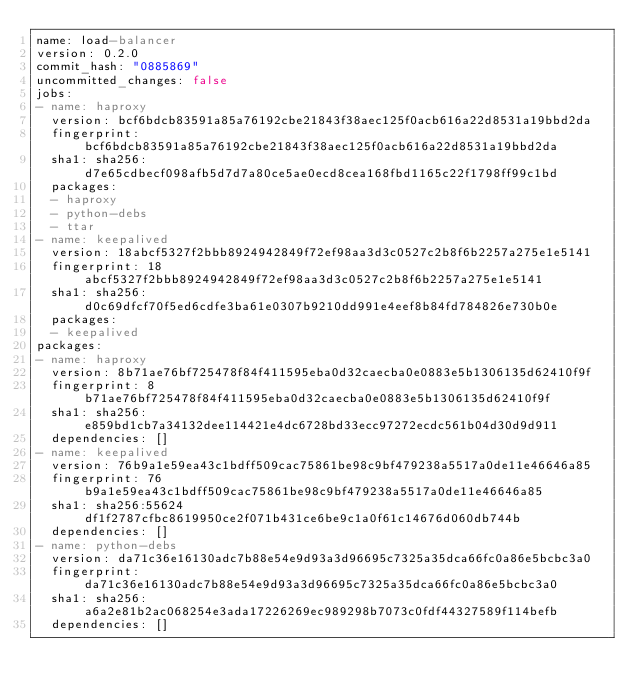<code> <loc_0><loc_0><loc_500><loc_500><_YAML_>name: load-balancer
version: 0.2.0
commit_hash: "0885869"
uncommitted_changes: false
jobs:
- name: haproxy
  version: bcf6bdcb83591a85a76192cbe21843f38aec125f0acb616a22d8531a19bbd2da
  fingerprint: bcf6bdcb83591a85a76192cbe21843f38aec125f0acb616a22d8531a19bbd2da
  sha1: sha256:d7e65cdbecf098afb5d7d7a80ce5ae0ecd8cea168fbd1165c22f1798ff99c1bd
  packages:
  - haproxy
  - python-debs
  - ttar
- name: keepalived
  version: 18abcf5327f2bbb8924942849f72ef98aa3d3c0527c2b8f6b2257a275e1e5141
  fingerprint: 18abcf5327f2bbb8924942849f72ef98aa3d3c0527c2b8f6b2257a275e1e5141
  sha1: sha256:d0c69dfcf70f5ed6cdfe3ba61e0307b9210dd991e4eef8b84fd784826e730b0e
  packages:
  - keepalived
packages:
- name: haproxy
  version: 8b71ae76bf725478f84f411595eba0d32caecba0e0883e5b1306135d62410f9f
  fingerprint: 8b71ae76bf725478f84f411595eba0d32caecba0e0883e5b1306135d62410f9f
  sha1: sha256:e859bd1cb7a34132dee114421e4dc6728bd33ecc97272ecdc561b04d30d9d911
  dependencies: []
- name: keepalived
  version: 76b9a1e59ea43c1bdff509cac75861be98c9bf479238a5517a0de11e46646a85
  fingerprint: 76b9a1e59ea43c1bdff509cac75861be98c9bf479238a5517a0de11e46646a85
  sha1: sha256:55624df1f2787cfbc8619950ce2f071b431ce6be9c1a0f61c14676d060db744b
  dependencies: []
- name: python-debs
  version: da71c36e16130adc7b88e54e9d93a3d96695c7325a35dca66fc0a86e5bcbc3a0
  fingerprint: da71c36e16130adc7b88e54e9d93a3d96695c7325a35dca66fc0a86e5bcbc3a0
  sha1: sha256:a6a2e81b2ac068254e3ada17226269ec989298b7073c0fdf44327589f114befb
  dependencies: []</code> 